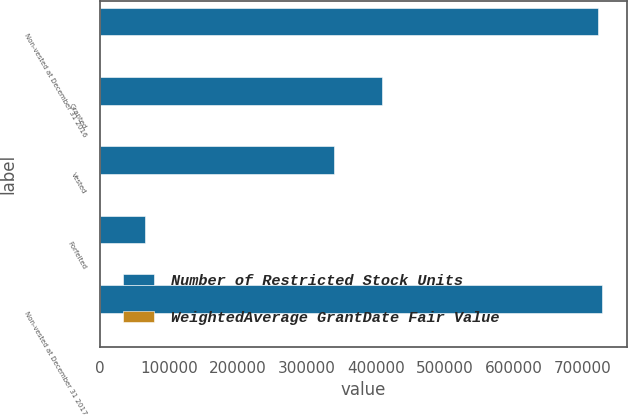Convert chart. <chart><loc_0><loc_0><loc_500><loc_500><stacked_bar_chart><ecel><fcel>Non-vested at December 31 2016<fcel>Granted<fcel>Vested<fcel>Forfeited<fcel>Non-vested at December 31 2017<nl><fcel>Number of Restricted Stock Units<fcel>723398<fcel>408608<fcel>338988<fcel>64953<fcel>728065<nl><fcel>WeightedAverage GrantDate Fair Value<fcel>49.22<fcel>58.59<fcel>48.13<fcel>53.56<fcel>54.59<nl></chart> 